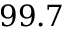Convert formula to latex. <formula><loc_0><loc_0><loc_500><loc_500>9 9 . 7</formula> 